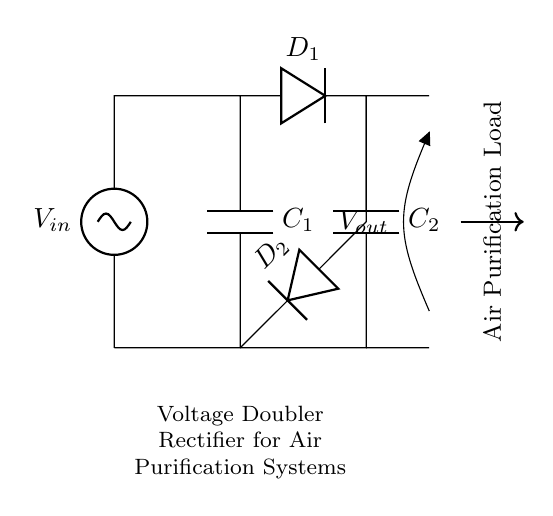What is the input voltage labeled as in the circuit? The input voltage is labeled as 'V_in' at the left side of the circuit diagram, indicating the voltage entering the rectifier.
Answer: V_in What components are used in this voltage doubler rectifier? The components used in this rectifier are two capacitors labeled as C1 and C2, and two diodes labeled as D1 and D2.
Answer: C1, C2, D1, D2 What does the output voltage lead to in this circuit? The output voltage leads to an open connection labeled 'V_out' which indicates where the boosted voltage will be delivered to the load, specifically the air purification system.
Answer: V_out What is the purpose of the diodes in the circuit? The diodes D1 and D2 allow current to flow in one direction only, which is crucial for rectifying the AC input voltage to DC, thus contributing to the voltage doubling function of the circuit.
Answer: Rectification How many capacitors are present in this rectifier circuit? There are two capacitors present in the circuit, namely C1 at the top and C2 at the bottom of the diagram.
Answer: Two What effect does this circuit have on voltage? This circuit doubles the input voltage, making it suitable for applications that require higher voltage levels, like certain operations in air purification.
Answer: Doubles the voltage What is the load indicated in this circuit? The load is indicated as “Air Purification Load,” which suggests that the circuit is designed to power some air purification equipment.
Answer: Air Purification Load 